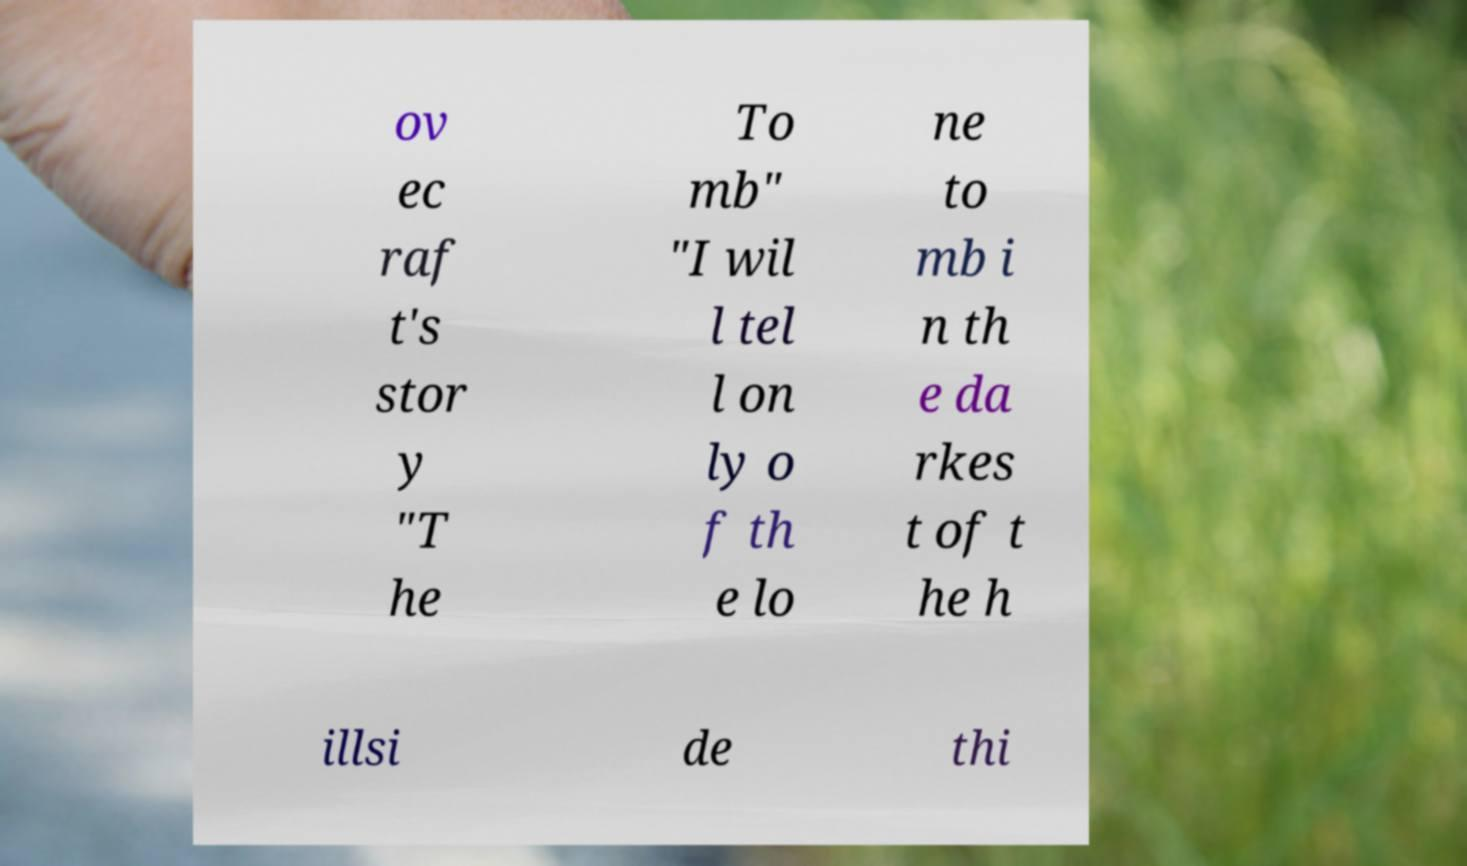There's text embedded in this image that I need extracted. Can you transcribe it verbatim? ov ec raf t's stor y "T he To mb" "I wil l tel l on ly o f th e lo ne to mb i n th e da rkes t of t he h illsi de thi 